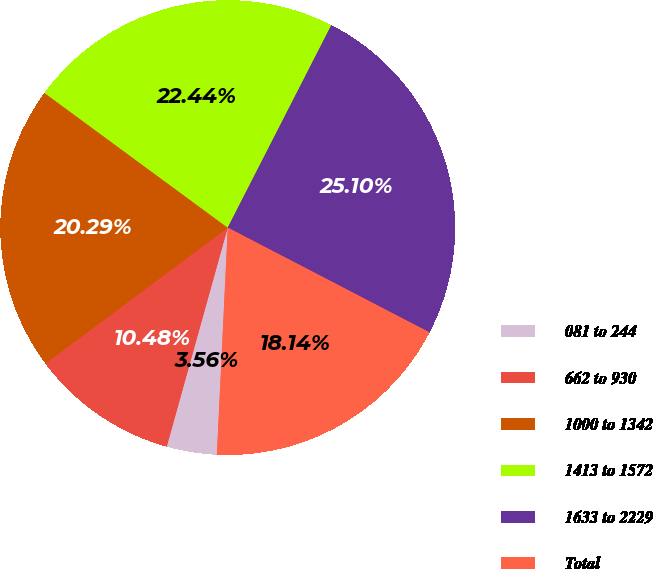Convert chart. <chart><loc_0><loc_0><loc_500><loc_500><pie_chart><fcel>081 to 244<fcel>662 to 930<fcel>1000 to 1342<fcel>1413 to 1572<fcel>1633 to 2229<fcel>Total<nl><fcel>3.56%<fcel>10.48%<fcel>20.29%<fcel>22.44%<fcel>25.1%<fcel>18.14%<nl></chart> 